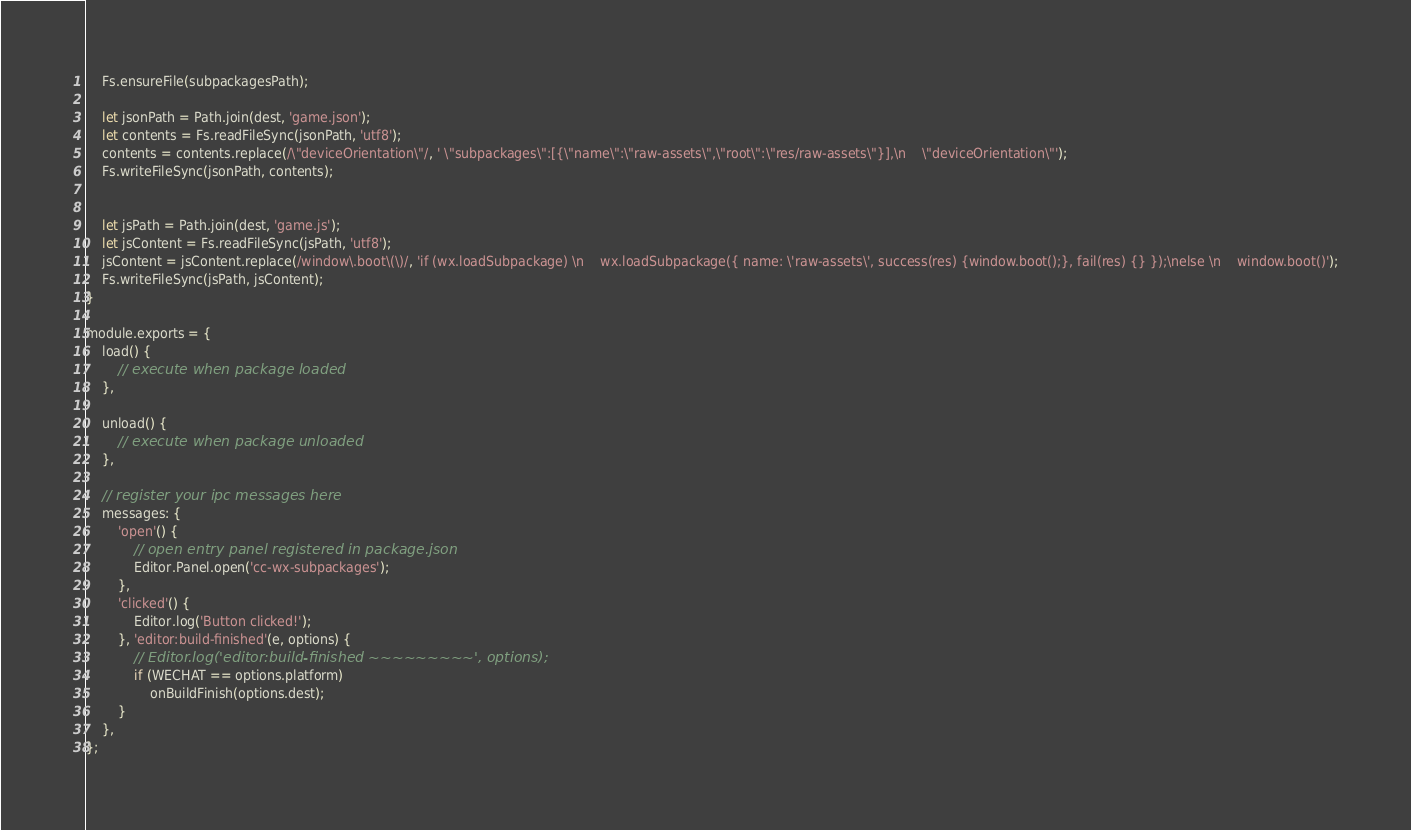<code> <loc_0><loc_0><loc_500><loc_500><_JavaScript_>    Fs.ensureFile(subpackagesPath);

    let jsonPath = Path.join(dest, 'game.json');
    let contents = Fs.readFileSync(jsonPath, 'utf8');
    contents = contents.replace(/\"deviceOrientation\"/, ' \"subpackages\":[{\"name\":\"raw-assets\",\"root\":\"res/raw-assets\"}],\n    \"deviceOrientation\"');
    Fs.writeFileSync(jsonPath, contents);


    let jsPath = Path.join(dest, 'game.js');
    let jsContent = Fs.readFileSync(jsPath, 'utf8');
    jsContent = jsContent.replace(/window\.boot\(\)/, 'if (wx.loadSubpackage) \n    wx.loadSubpackage({ name: \'raw-assets\', success(res) {window.boot();}, fail(res) {} });\nelse \n    window.boot()');
    Fs.writeFileSync(jsPath, jsContent);
}

module.exports = {
    load() {
        // execute when package loaded
    },

    unload() {
        // execute when package unloaded
    },

    // register your ipc messages here
    messages: {
        'open'() {
            // open entry panel registered in package.json
            Editor.Panel.open('cc-wx-subpackages');
        },
        'clicked'() {
            Editor.log('Button clicked!');
        }, 'editor:build-finished'(e, options) {
            // Editor.log('editor:build-finished ~~~~~~~~~', options);
            if (WECHAT == options.platform)
                onBuildFinish(options.dest);
        }
    },
};</code> 